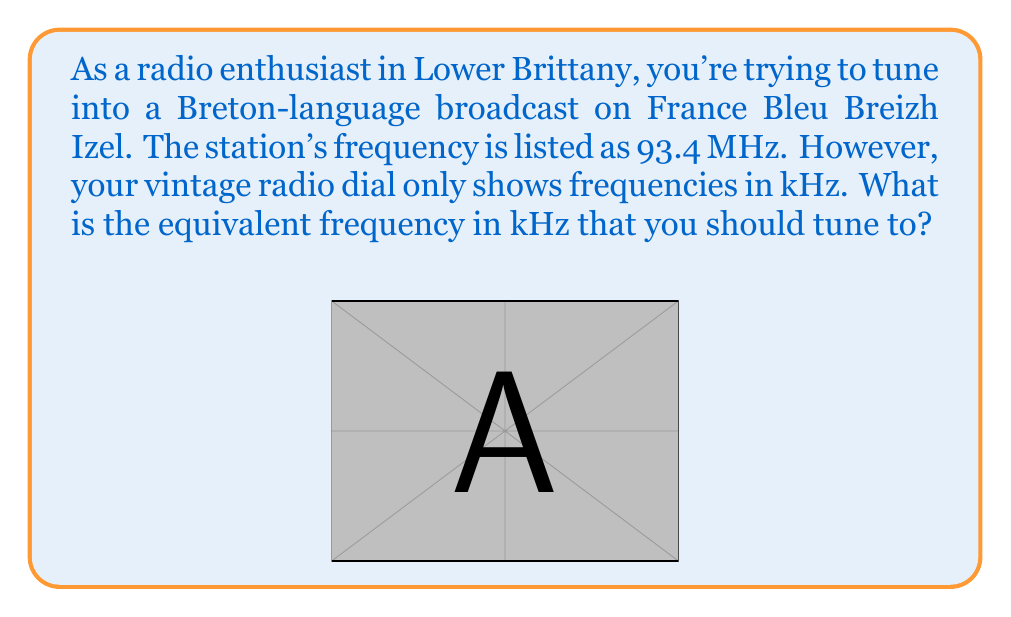Give your solution to this math problem. To convert from MHz to kHz, we need to multiply the frequency by 1000. This is because:

1 MHz = 1000 kHz

Let's break down the conversion step-by-step:

1) We start with 93.4 MHz

2) Set up the conversion:
   $93.4 \text{ MHz} \times \frac{1000 \text{ kHz}}{1 \text{ MHz}}$

3) The units of MHz cancel out:
   $93.4 \cancel{\text{MHz}} \times \frac{1000 \text{ kHz}}{\cancel{1 \text{ MHz}}} = 93.4 \times 1000 \text{ kHz}$

4) Multiply:
   $93.4 \times 1000 = 93400 \text{ kHz}$

Therefore, 93.4 MHz is equivalent to 93400 kHz.
Answer: 93400 kHz 